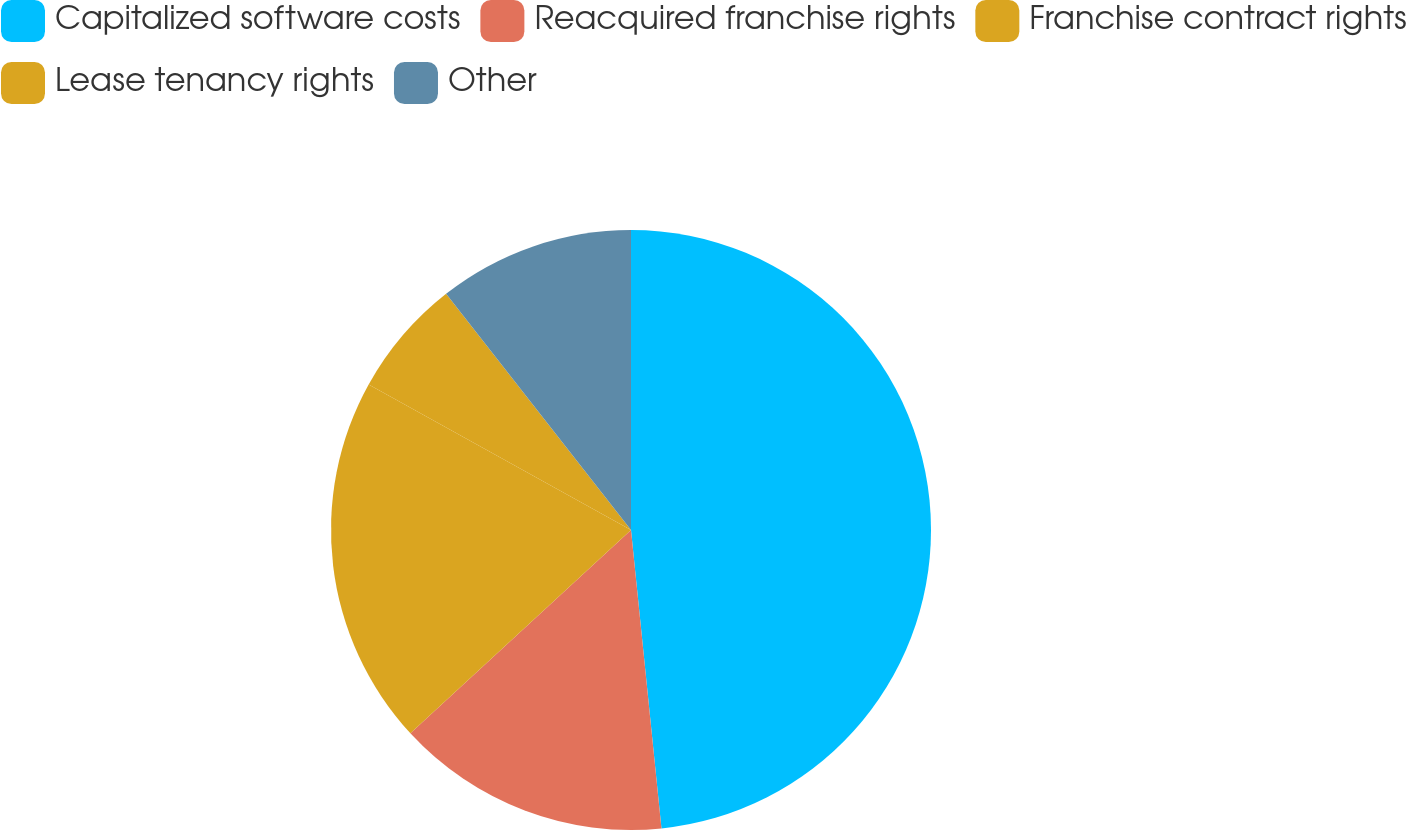<chart> <loc_0><loc_0><loc_500><loc_500><pie_chart><fcel>Capitalized software costs<fcel>Reacquired franchise rights<fcel>Franchise contract rights<fcel>Lease tenancy rights<fcel>Other<nl><fcel>48.38%<fcel>14.77%<fcel>19.91%<fcel>6.37%<fcel>10.57%<nl></chart> 